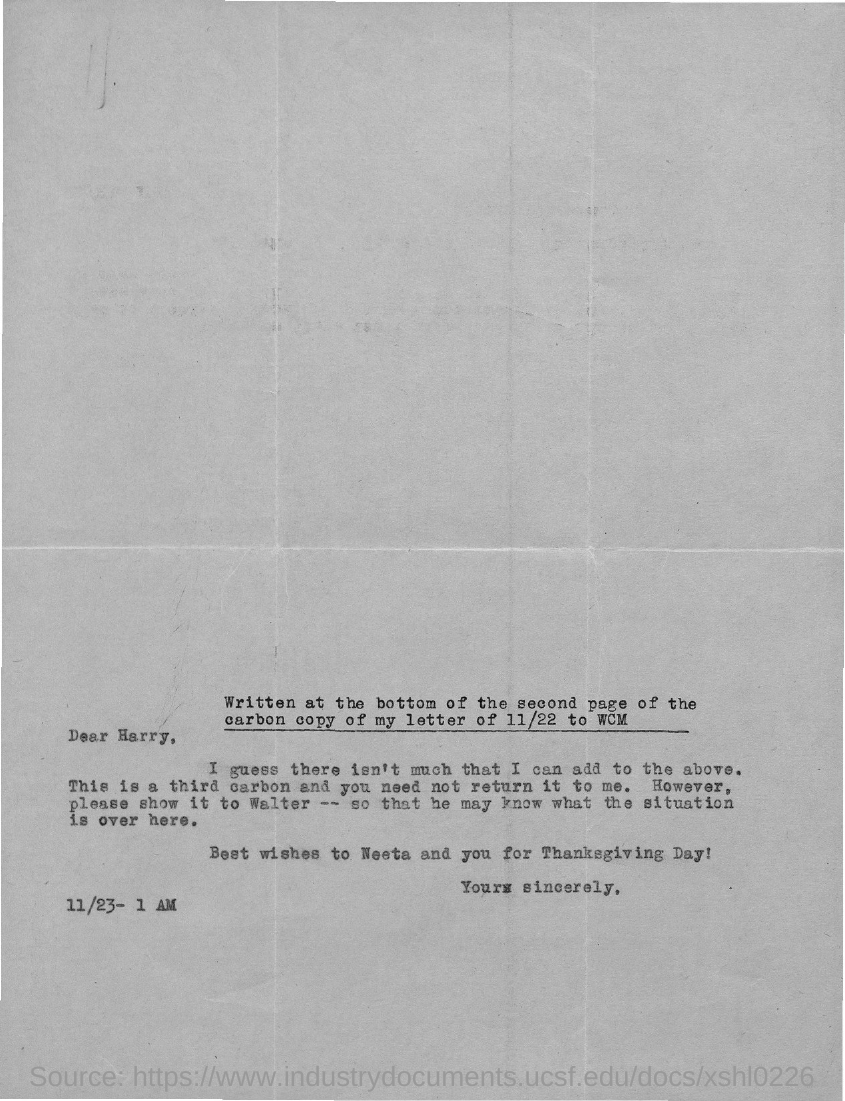The letter is addressed to which person?
Your answer should be compact. Harry. 